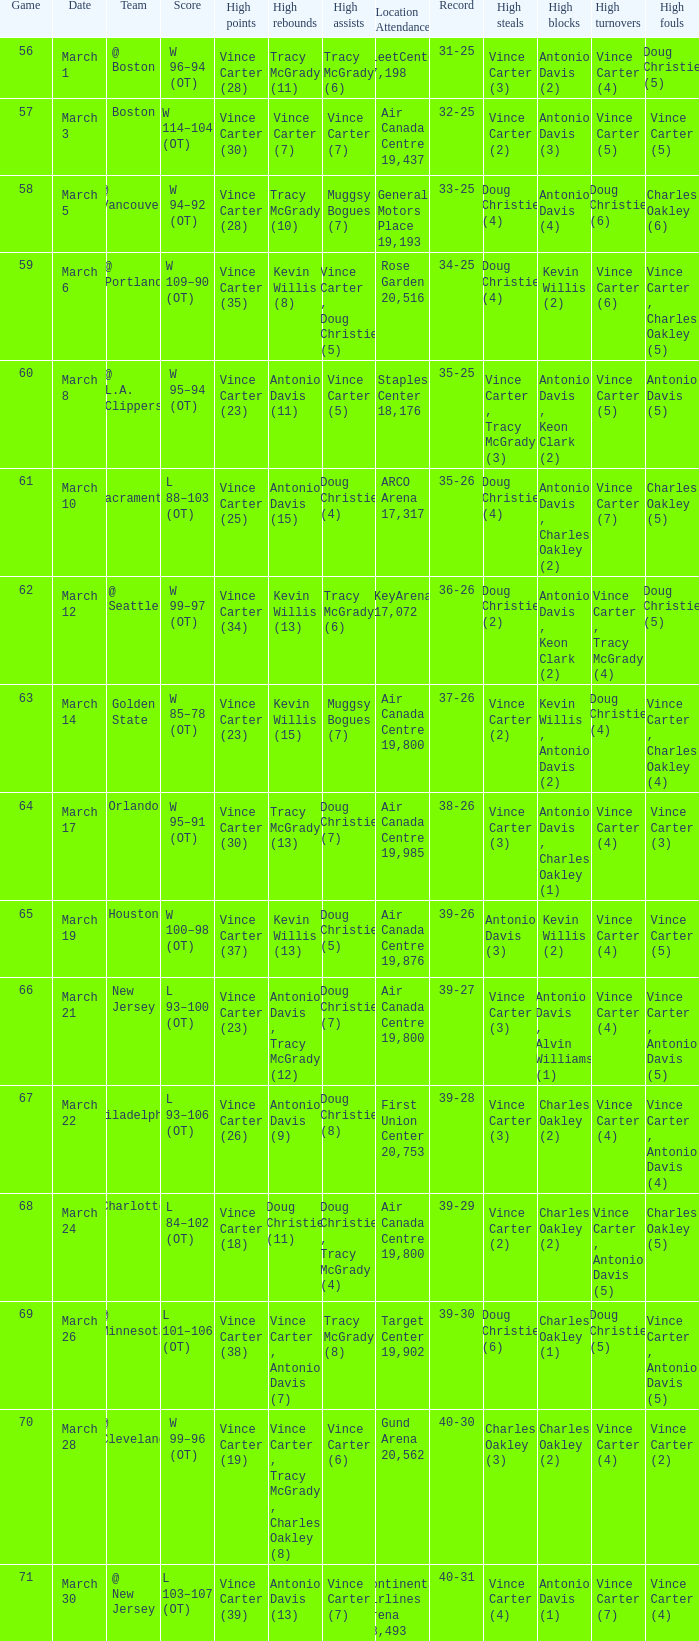What day was the attendance at the staples center 18,176? March 8. 